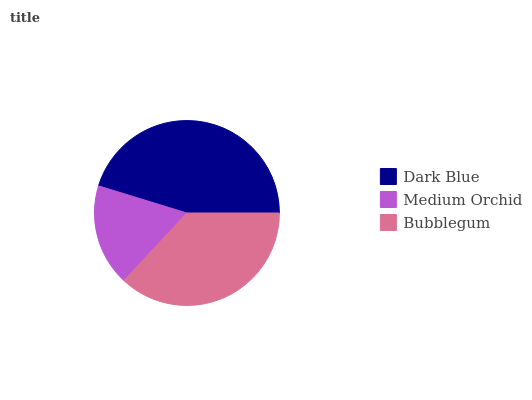Is Medium Orchid the minimum?
Answer yes or no. Yes. Is Dark Blue the maximum?
Answer yes or no. Yes. Is Bubblegum the minimum?
Answer yes or no. No. Is Bubblegum the maximum?
Answer yes or no. No. Is Bubblegum greater than Medium Orchid?
Answer yes or no. Yes. Is Medium Orchid less than Bubblegum?
Answer yes or no. Yes. Is Medium Orchid greater than Bubblegum?
Answer yes or no. No. Is Bubblegum less than Medium Orchid?
Answer yes or no. No. Is Bubblegum the high median?
Answer yes or no. Yes. Is Bubblegum the low median?
Answer yes or no. Yes. Is Medium Orchid the high median?
Answer yes or no. No. Is Dark Blue the low median?
Answer yes or no. No. 